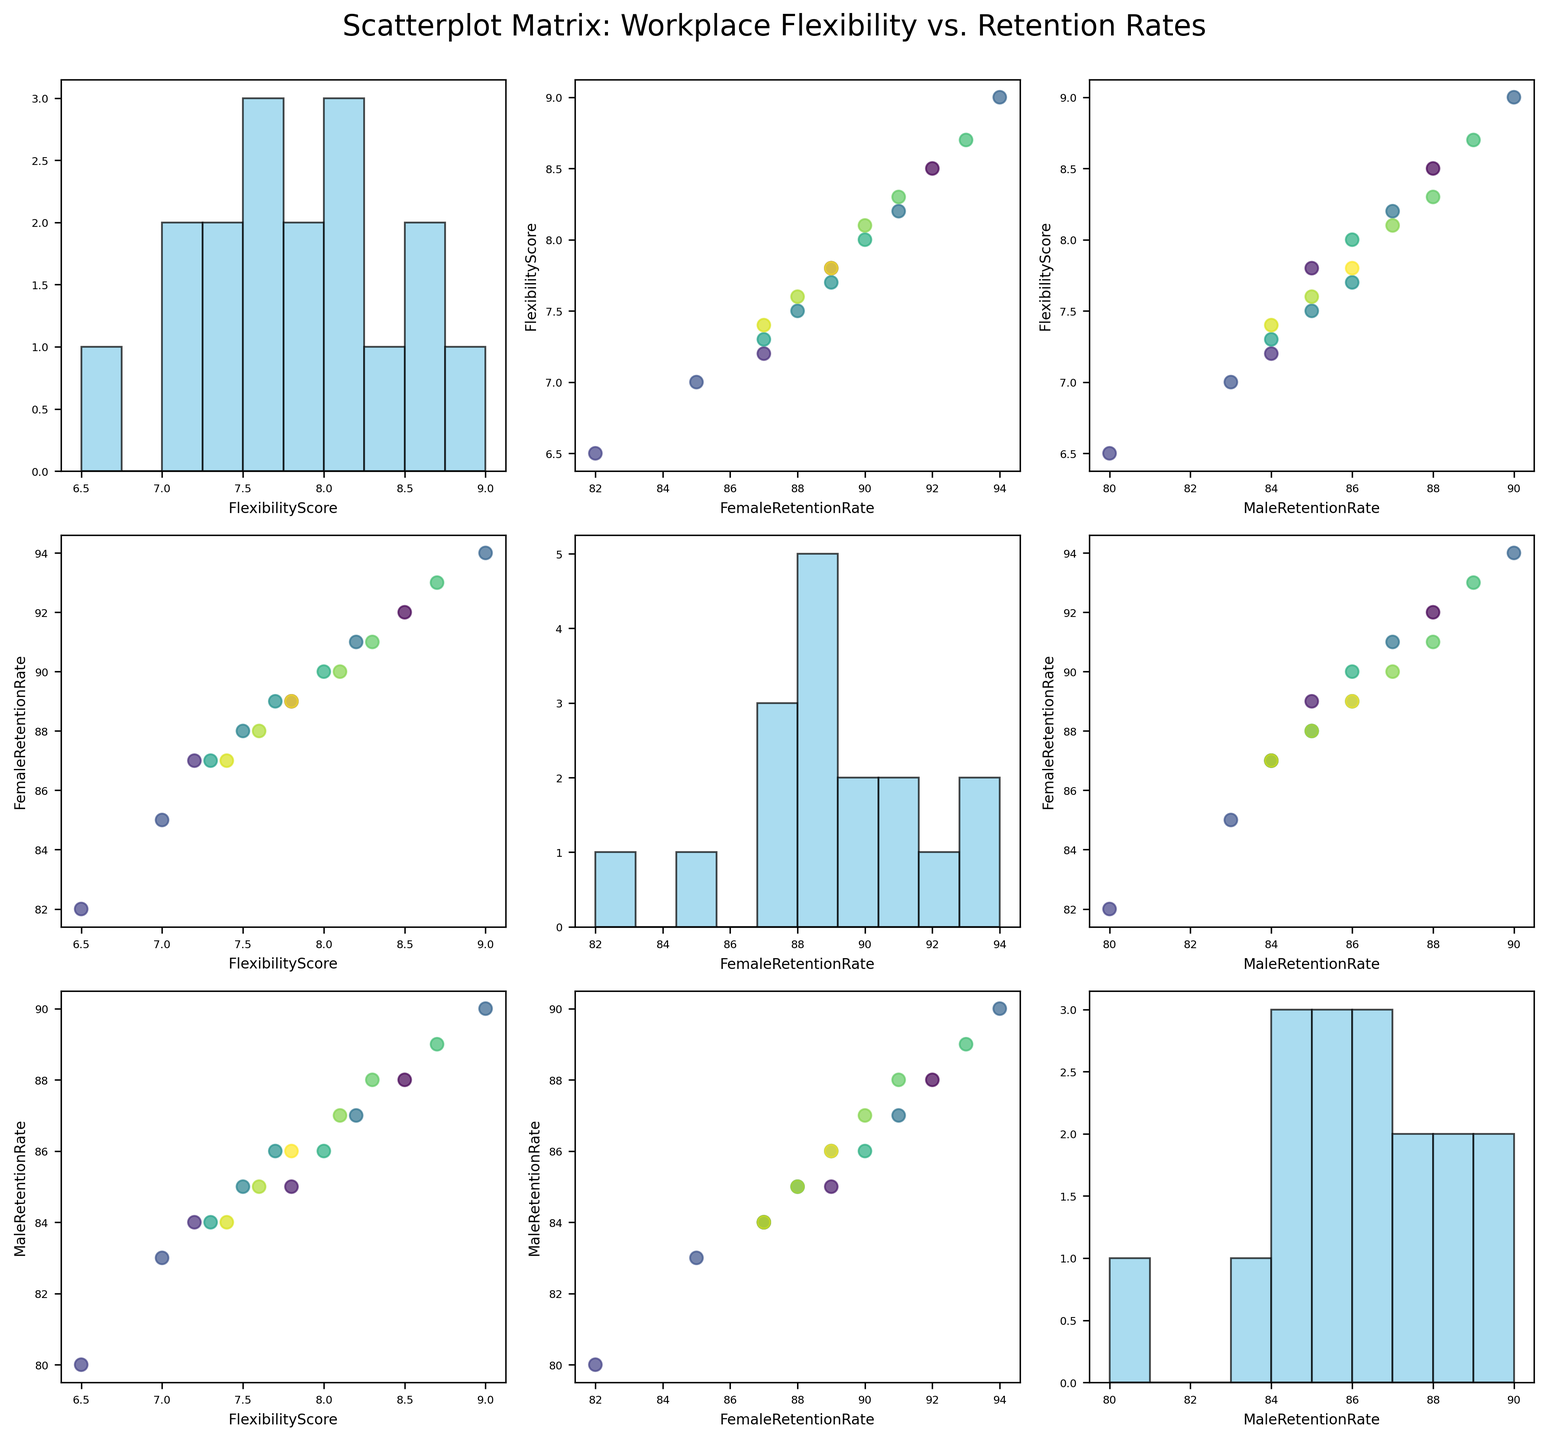What is the title of the figure? The title of the figure is located at the top and larger than other text, making it easy to identify.
Answer: Scatterplot Matrix: Workplace Flexibility vs. Retention Rates How many variables are visualized in the scatterplot matrix? The scatterplot matrix typically includes all the listed variables on both axes. You can count the number of unique variable names to find the answer.
Answer: Three How many bins are used in the histograms along the diagonal of the scatterplot matrix? Looking at the histograms along the diagonal, count the number of bins or bars in one of the histograms. This pattern is consistent across all histograms.
Answer: Ten Which company shows the highest female retention rate based on the scatterplot points? Observing the scatter points along the FemaleRetentionRate axis, look for the highest point on this axis and identify the corresponding company.
Answer: Salesforce Does a higher FlexibilityScore correlate with a higher FemaleRetentionRate? Compare the scatter points in the plot between FlexibilityScore and FemaleRetentionRate. A generally upward trend would indicate a positive correlation.
Answer: Yes Which variable has the most spread in its histogram? Look at the histograms along the diagonal and compare the spread (width and variance) of data points across different variables.
Answer: FlexibilityScore Is the MaleRetentionRate generally higher or lower than the FemaleRetentionRate? Compare the positioning of points in the scatter plots between FemaleRetentionRate and MaleRetentionRate by observing if they trend higher or lower.
Answer: Lower Are any companies outliers in terms of FlexibilityScore? Look at the FlexibilityScore histograms and scatter plots to see if any company's score significantly deviates from the cluster of other companies.
Answer: Google (highest) and Amazon (lowest) What is the average retention rate for males across all companies? Locate and sum all the values for MaleRetentionRate from the scatter points or the data, then divide by the number of companies.
Answer: (88+85+84+80+83+90+87+85+86+84+86+89+88+87+85+84+86) / 17 = 86.12 Between FlexibilityScore and FemaleRetentionRate, which one seems more variable based on their respective histograms? Compare the spread and density of the bars in the histograms of FlexibilityScore and FemaleRetentionRate to determine which histogram shows greater variability.
Answer: FlexibilityScore 